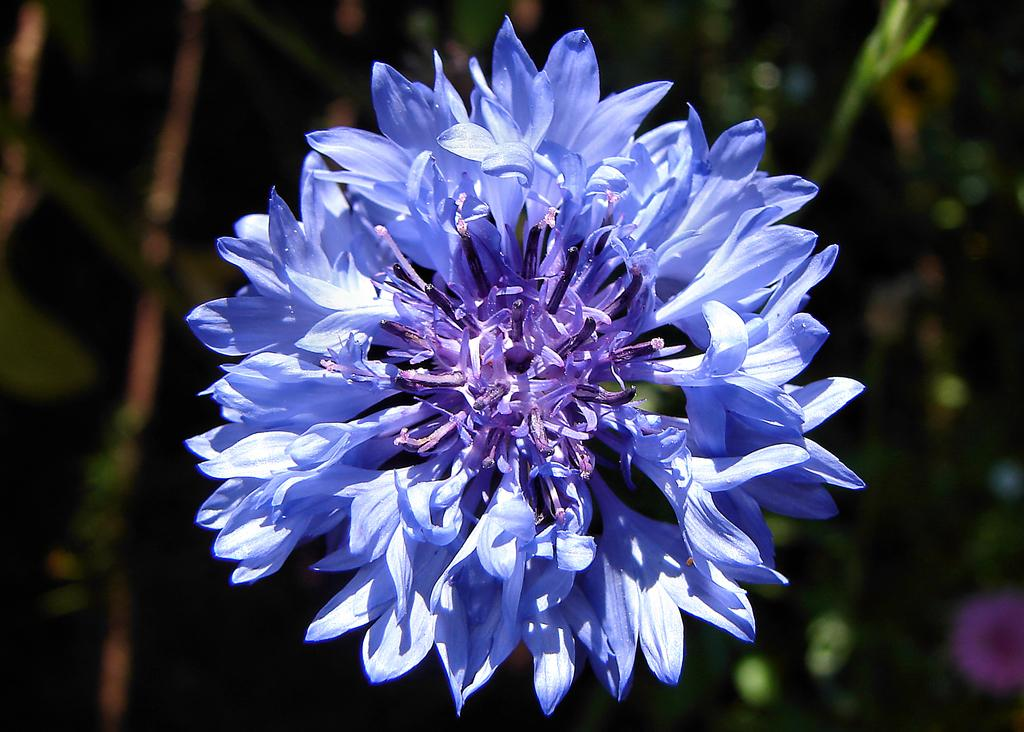What is the main subject of the image? There is a flower in the image. Can you describe the background of the image? The background of the image is blurred. How does the flower pull the car in the image? The flower does not pull the car in the image, as flowers do not have the ability to move or interact with cars. 